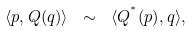<formula> <loc_0><loc_0><loc_500><loc_500>\langle { p } , { Q } ( { q } ) \rangle \ \sim \ \langle { Q } ^ { ^ { * } } ( { p } ) , { q } \rangle ,</formula> 